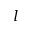<formula> <loc_0><loc_0><loc_500><loc_500>l</formula> 